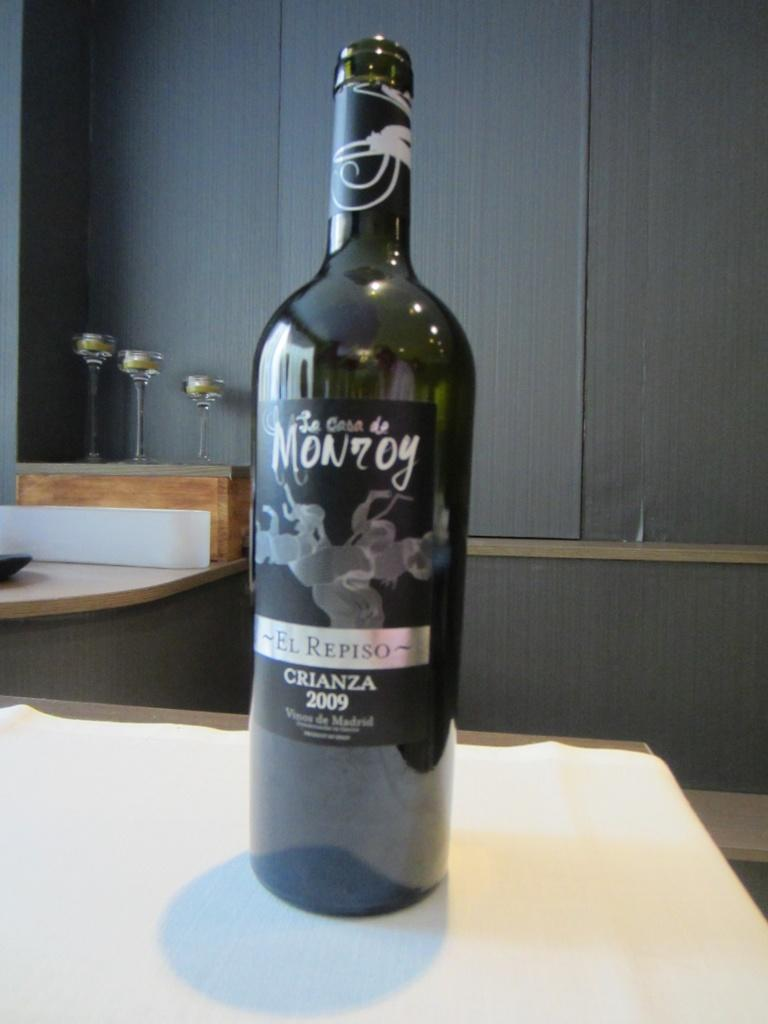<image>
Present a compact description of the photo's key features. A bottle on the table has "CRIANZA 2009" on the label. 